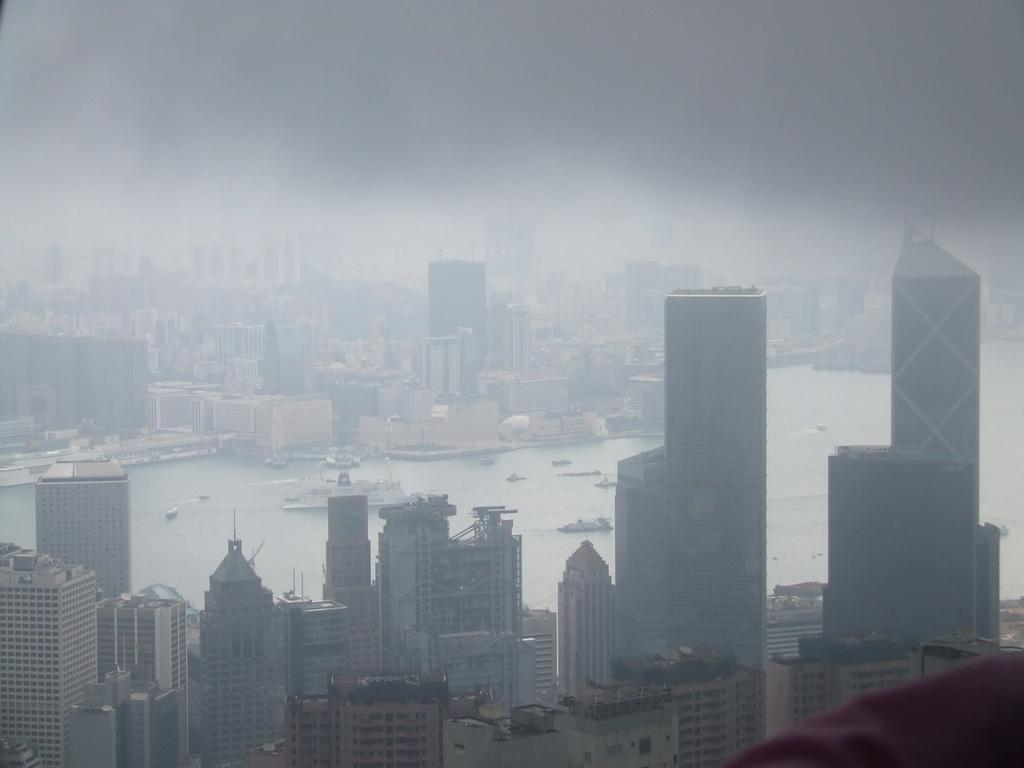What type of structures are present in the image? There are skyscrapers and buildings in the image. Can you describe the water-based vehicles in the image? There is a ship visible in the image, as well as boats on the water. How many chairs are placed on the ship in the image? There are no chairs visible on the ship in the image. What type of rice is being served on the boats in the image? There is no rice present in the image; it features skyscrapers, buildings, a ship, and boats on the water. 